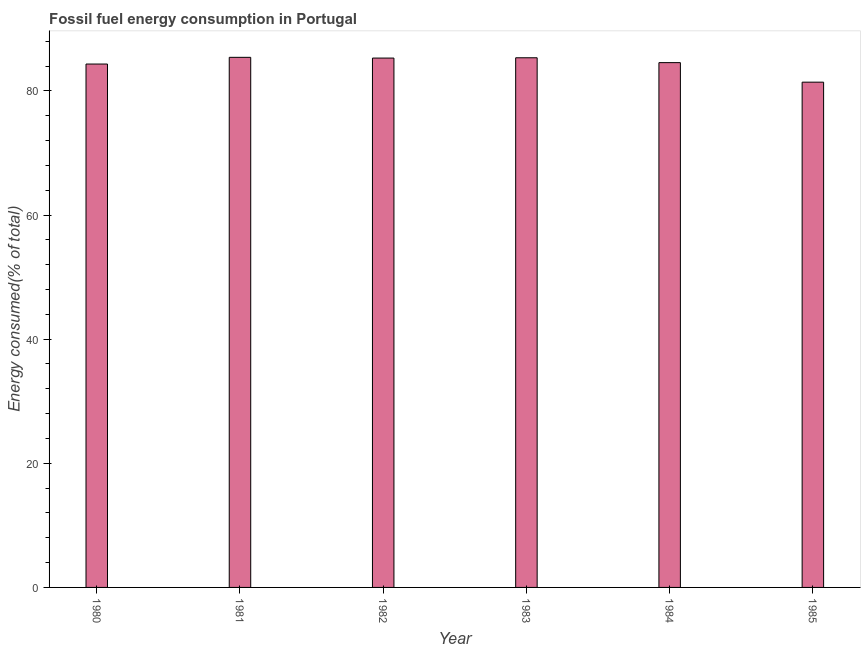Does the graph contain grids?
Provide a succinct answer. No. What is the title of the graph?
Your response must be concise. Fossil fuel energy consumption in Portugal. What is the label or title of the Y-axis?
Your answer should be very brief. Energy consumed(% of total). What is the fossil fuel energy consumption in 1983?
Provide a short and direct response. 85.33. Across all years, what is the maximum fossil fuel energy consumption?
Offer a very short reply. 85.4. Across all years, what is the minimum fossil fuel energy consumption?
Your response must be concise. 81.4. What is the sum of the fossil fuel energy consumption?
Provide a short and direct response. 506.3. What is the difference between the fossil fuel energy consumption in 1982 and 1985?
Your answer should be very brief. 3.88. What is the average fossil fuel energy consumption per year?
Offer a very short reply. 84.38. What is the median fossil fuel energy consumption?
Give a very brief answer. 84.92. What is the ratio of the fossil fuel energy consumption in 1981 to that in 1984?
Your answer should be compact. 1.01. Is the difference between the fossil fuel energy consumption in 1984 and 1985 greater than the difference between any two years?
Give a very brief answer. No. What is the difference between the highest and the second highest fossil fuel energy consumption?
Your response must be concise. 0.07. Is the sum of the fossil fuel energy consumption in 1981 and 1984 greater than the maximum fossil fuel energy consumption across all years?
Provide a succinct answer. Yes. In how many years, is the fossil fuel energy consumption greater than the average fossil fuel energy consumption taken over all years?
Your answer should be very brief. 4. How many bars are there?
Your answer should be very brief. 6. What is the difference between two consecutive major ticks on the Y-axis?
Ensure brevity in your answer.  20. Are the values on the major ticks of Y-axis written in scientific E-notation?
Ensure brevity in your answer.  No. What is the Energy consumed(% of total) in 1980?
Your answer should be very brief. 84.32. What is the Energy consumed(% of total) of 1981?
Give a very brief answer. 85.4. What is the Energy consumed(% of total) of 1982?
Make the answer very short. 85.28. What is the Energy consumed(% of total) of 1983?
Make the answer very short. 85.33. What is the Energy consumed(% of total) of 1984?
Keep it short and to the point. 84.55. What is the Energy consumed(% of total) in 1985?
Offer a terse response. 81.4. What is the difference between the Energy consumed(% of total) in 1980 and 1981?
Keep it short and to the point. -1.08. What is the difference between the Energy consumed(% of total) in 1980 and 1982?
Your answer should be compact. -0.96. What is the difference between the Energy consumed(% of total) in 1980 and 1983?
Your response must be concise. -1.01. What is the difference between the Energy consumed(% of total) in 1980 and 1984?
Make the answer very short. -0.23. What is the difference between the Energy consumed(% of total) in 1980 and 1985?
Offer a very short reply. 2.92. What is the difference between the Energy consumed(% of total) in 1981 and 1982?
Offer a terse response. 0.12. What is the difference between the Energy consumed(% of total) in 1981 and 1983?
Your answer should be compact. 0.07. What is the difference between the Energy consumed(% of total) in 1981 and 1984?
Your answer should be very brief. 0.85. What is the difference between the Energy consumed(% of total) in 1981 and 1985?
Your answer should be compact. 4. What is the difference between the Energy consumed(% of total) in 1982 and 1983?
Your answer should be compact. -0.05. What is the difference between the Energy consumed(% of total) in 1982 and 1984?
Give a very brief answer. 0.73. What is the difference between the Energy consumed(% of total) in 1982 and 1985?
Ensure brevity in your answer.  3.88. What is the difference between the Energy consumed(% of total) in 1983 and 1984?
Your response must be concise. 0.78. What is the difference between the Energy consumed(% of total) in 1983 and 1985?
Offer a terse response. 3.93. What is the difference between the Energy consumed(% of total) in 1984 and 1985?
Offer a terse response. 3.15. What is the ratio of the Energy consumed(% of total) in 1980 to that in 1981?
Your answer should be compact. 0.99. What is the ratio of the Energy consumed(% of total) in 1980 to that in 1982?
Give a very brief answer. 0.99. What is the ratio of the Energy consumed(% of total) in 1980 to that in 1984?
Ensure brevity in your answer.  1. What is the ratio of the Energy consumed(% of total) in 1980 to that in 1985?
Your answer should be very brief. 1.04. What is the ratio of the Energy consumed(% of total) in 1981 to that in 1984?
Offer a terse response. 1.01. What is the ratio of the Energy consumed(% of total) in 1981 to that in 1985?
Give a very brief answer. 1.05. What is the ratio of the Energy consumed(% of total) in 1982 to that in 1983?
Ensure brevity in your answer.  1. What is the ratio of the Energy consumed(% of total) in 1982 to that in 1985?
Provide a succinct answer. 1.05. What is the ratio of the Energy consumed(% of total) in 1983 to that in 1984?
Offer a very short reply. 1.01. What is the ratio of the Energy consumed(% of total) in 1983 to that in 1985?
Your answer should be compact. 1.05. What is the ratio of the Energy consumed(% of total) in 1984 to that in 1985?
Offer a very short reply. 1.04. 